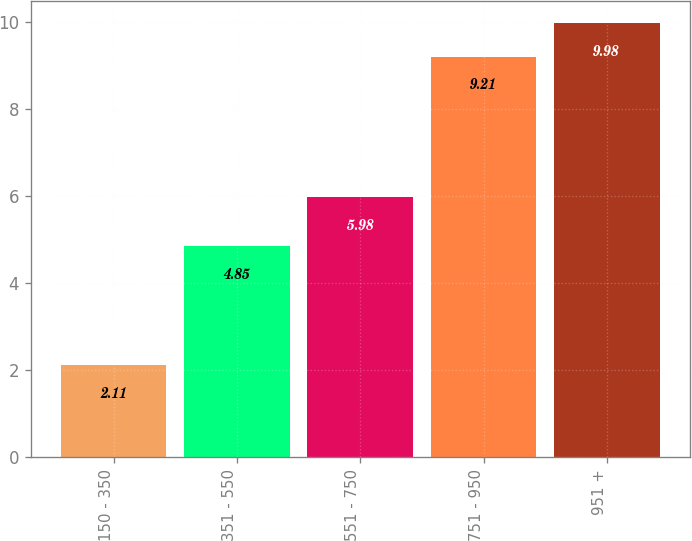Convert chart. <chart><loc_0><loc_0><loc_500><loc_500><bar_chart><fcel>150 - 350<fcel>351 - 550<fcel>551 - 750<fcel>751 - 950<fcel>951 +<nl><fcel>2.11<fcel>4.85<fcel>5.98<fcel>9.21<fcel>9.98<nl></chart> 